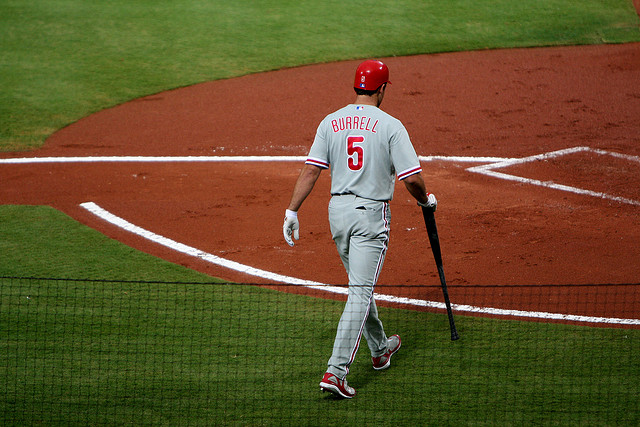<image>What brand are the man's shoes? I am not certain about the brand of the man's shoes. It can be nike or adidas. What brand are the man's shoes? I am not sure what brand are the man's shoes. It can be seen as Nike or Adidas. 